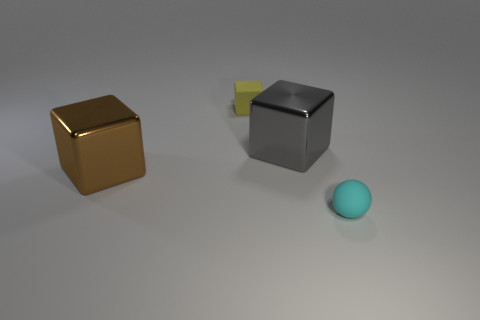Subtract all big shiny blocks. How many blocks are left? 1 Subtract 1 spheres. How many spheres are left? 0 Subtract all gray blocks. How many blocks are left? 2 Subtract all cubes. How many objects are left? 1 Add 4 brown rubber cylinders. How many objects exist? 8 Subtract 0 red blocks. How many objects are left? 4 Subtract all brown balls. Subtract all gray cubes. How many balls are left? 1 Subtract all yellow cylinders. How many brown spheres are left? 0 Subtract all large brown metal cubes. Subtract all cyan objects. How many objects are left? 2 Add 3 metal cubes. How many metal cubes are left? 5 